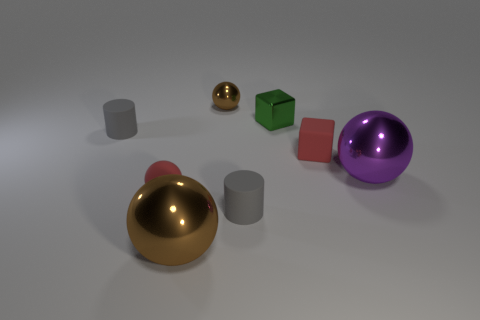Is the number of red cubes behind the large purple sphere greater than the number of large purple balls that are on the left side of the red matte sphere?
Offer a terse response. Yes. How many metallic objects are cubes or small brown spheres?
Make the answer very short. 2. There is a object that is the same color as the matte block; what material is it?
Keep it short and to the point. Rubber. Are there fewer tiny brown objects to the left of the small red ball than tiny red matte objects on the left side of the green thing?
Keep it short and to the point. Yes. How many objects are tiny red spheres or objects that are on the left side of the tiny red rubber block?
Your answer should be very brief. 6. There is a brown thing that is the same size as the purple shiny sphere; what is its material?
Offer a terse response. Metal. Do the tiny red ball and the tiny red cube have the same material?
Provide a succinct answer. Yes. The object that is both to the right of the small brown metal object and in front of the tiny red ball is what color?
Your answer should be very brief. Gray. There is a tiny matte ball in front of the tiny green metal block; does it have the same color as the matte cube?
Offer a very short reply. Yes. The object that is the same size as the purple metal sphere is what shape?
Keep it short and to the point. Sphere. 